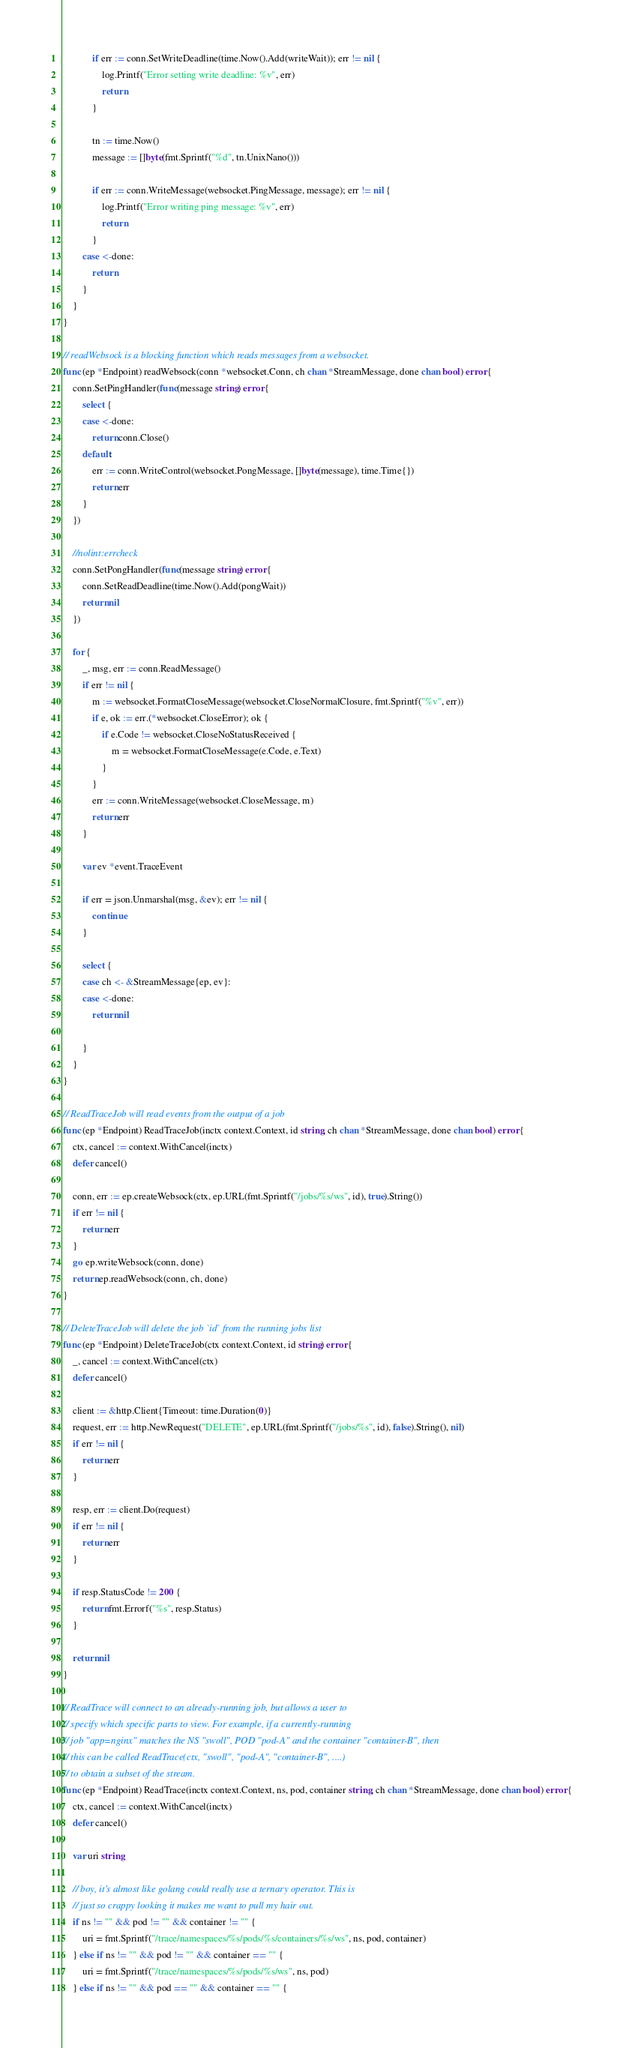Convert code to text. <code><loc_0><loc_0><loc_500><loc_500><_Go_>			if err := conn.SetWriteDeadline(time.Now().Add(writeWait)); err != nil {
				log.Printf("Error setting write deadline: %v", err)
				return
			}

			tn := time.Now()
			message := []byte(fmt.Sprintf("%d", tn.UnixNano()))

			if err := conn.WriteMessage(websocket.PingMessage, message); err != nil {
				log.Printf("Error writing ping message: %v", err)
				return
			}
		case <-done:
			return
		}
	}
}

// readWebsock is a blocking function which reads messages from a websocket.
func (ep *Endpoint) readWebsock(conn *websocket.Conn, ch chan *StreamMessage, done chan bool) error {
	conn.SetPingHandler(func(message string) error {
		select {
		case <-done:
			return conn.Close()
		default:
			err := conn.WriteControl(websocket.PongMessage, []byte(message), time.Time{})
			return err
		}
	})

	//nolint:errcheck
	conn.SetPongHandler(func(message string) error {
		conn.SetReadDeadline(time.Now().Add(pongWait))
		return nil
	})

	for {
		_, msg, err := conn.ReadMessage()
		if err != nil {
			m := websocket.FormatCloseMessage(websocket.CloseNormalClosure, fmt.Sprintf("%v", err))
			if e, ok := err.(*websocket.CloseError); ok {
				if e.Code != websocket.CloseNoStatusReceived {
					m = websocket.FormatCloseMessage(e.Code, e.Text)
				}
			}
			err := conn.WriteMessage(websocket.CloseMessage, m)
			return err
		}

		var ev *event.TraceEvent

		if err = json.Unmarshal(msg, &ev); err != nil {
			continue
		}

		select {
		case ch <- &StreamMessage{ep, ev}:
		case <-done:
			return nil

		}
	}
}

// ReadTraceJob will read events from the output of a job
func (ep *Endpoint) ReadTraceJob(inctx context.Context, id string, ch chan *StreamMessage, done chan bool) error {
	ctx, cancel := context.WithCancel(inctx)
	defer cancel()

	conn, err := ep.createWebsock(ctx, ep.URL(fmt.Sprintf("/jobs/%s/ws", id), true).String())
	if err != nil {
		return err
	}
	go ep.writeWebsock(conn, done)
	return ep.readWebsock(conn, ch, done)
}

// DeleteTraceJob will delete the job `id` from the running jobs list
func (ep *Endpoint) DeleteTraceJob(ctx context.Context, id string) error {
	_, cancel := context.WithCancel(ctx)
	defer cancel()

	client := &http.Client{Timeout: time.Duration(0)}
	request, err := http.NewRequest("DELETE", ep.URL(fmt.Sprintf("/jobs/%s", id), false).String(), nil)
	if err != nil {
		return err
	}

	resp, err := client.Do(request)
	if err != nil {
		return err
	}

	if resp.StatusCode != 200 {
		return fmt.Errorf("%s", resp.Status)
	}

	return nil
}

// ReadTrace will connect to an already-running job, but allows a user to
// specify which specific parts to view. For example, if a currently-running
// job "app=nginx" matches the NS "swoll", POD "pod-A" and the container "container-B", then
// this can be called ReadTrace(ctx, "swoll", "pod-A", "container-B", ....)
// to obtain a subset of the stream.
func (ep *Endpoint) ReadTrace(inctx context.Context, ns, pod, container string, ch chan *StreamMessage, done chan bool) error {
	ctx, cancel := context.WithCancel(inctx)
	defer cancel()

	var uri string

	// boy, it's almost like golang could really use a ternary operator. This is
	// just so crappy looking it makes me want to pull my hair out.
	if ns != "" && pod != "" && container != "" {
		uri = fmt.Sprintf("/trace/namespaces/%s/pods/%s/containers/%s/ws", ns, pod, container)
	} else if ns != "" && pod != "" && container == "" {
		uri = fmt.Sprintf("/trace/namespaces/%s/pods/%s/ws", ns, pod)
	} else if ns != "" && pod == "" && container == "" {</code> 